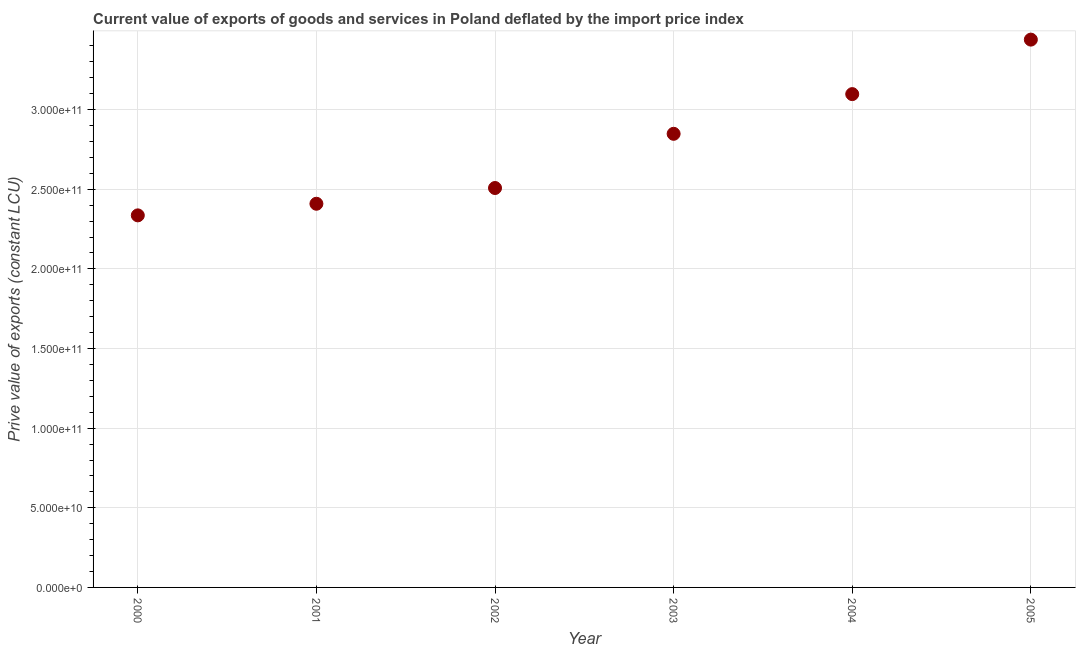What is the price value of exports in 2005?
Your answer should be very brief. 3.44e+11. Across all years, what is the maximum price value of exports?
Your answer should be compact. 3.44e+11. Across all years, what is the minimum price value of exports?
Your answer should be compact. 2.34e+11. In which year was the price value of exports maximum?
Offer a very short reply. 2005. What is the sum of the price value of exports?
Offer a terse response. 1.66e+12. What is the difference between the price value of exports in 2000 and 2003?
Your answer should be very brief. -5.12e+1. What is the average price value of exports per year?
Make the answer very short. 2.77e+11. What is the median price value of exports?
Keep it short and to the point. 2.68e+11. In how many years, is the price value of exports greater than 200000000000 LCU?
Keep it short and to the point. 6. Do a majority of the years between 2005 and 2004 (inclusive) have price value of exports greater than 160000000000 LCU?
Give a very brief answer. No. What is the ratio of the price value of exports in 2004 to that in 2005?
Provide a succinct answer. 0.9. Is the price value of exports in 2004 less than that in 2005?
Offer a very short reply. Yes. Is the difference between the price value of exports in 2001 and 2004 greater than the difference between any two years?
Provide a short and direct response. No. What is the difference between the highest and the second highest price value of exports?
Give a very brief answer. 3.42e+1. Is the sum of the price value of exports in 2002 and 2003 greater than the maximum price value of exports across all years?
Your response must be concise. Yes. What is the difference between the highest and the lowest price value of exports?
Provide a succinct answer. 1.10e+11. How many years are there in the graph?
Keep it short and to the point. 6. Does the graph contain grids?
Your response must be concise. Yes. What is the title of the graph?
Your answer should be very brief. Current value of exports of goods and services in Poland deflated by the import price index. What is the label or title of the Y-axis?
Provide a short and direct response. Prive value of exports (constant LCU). What is the Prive value of exports (constant LCU) in 2000?
Make the answer very short. 2.34e+11. What is the Prive value of exports (constant LCU) in 2001?
Make the answer very short. 2.41e+11. What is the Prive value of exports (constant LCU) in 2002?
Your answer should be very brief. 2.51e+11. What is the Prive value of exports (constant LCU) in 2003?
Offer a terse response. 2.85e+11. What is the Prive value of exports (constant LCU) in 2004?
Your response must be concise. 3.10e+11. What is the Prive value of exports (constant LCU) in 2005?
Ensure brevity in your answer.  3.44e+11. What is the difference between the Prive value of exports (constant LCU) in 2000 and 2001?
Keep it short and to the point. -7.29e+09. What is the difference between the Prive value of exports (constant LCU) in 2000 and 2002?
Your answer should be compact. -1.72e+1. What is the difference between the Prive value of exports (constant LCU) in 2000 and 2003?
Your answer should be compact. -5.12e+1. What is the difference between the Prive value of exports (constant LCU) in 2000 and 2004?
Provide a succinct answer. -7.61e+1. What is the difference between the Prive value of exports (constant LCU) in 2000 and 2005?
Keep it short and to the point. -1.10e+11. What is the difference between the Prive value of exports (constant LCU) in 2001 and 2002?
Offer a very short reply. -9.88e+09. What is the difference between the Prive value of exports (constant LCU) in 2001 and 2003?
Provide a succinct answer. -4.39e+1. What is the difference between the Prive value of exports (constant LCU) in 2001 and 2004?
Your answer should be compact. -6.88e+1. What is the difference between the Prive value of exports (constant LCU) in 2001 and 2005?
Provide a succinct answer. -1.03e+11. What is the difference between the Prive value of exports (constant LCU) in 2002 and 2003?
Give a very brief answer. -3.40e+1. What is the difference between the Prive value of exports (constant LCU) in 2002 and 2004?
Provide a succinct answer. -5.90e+1. What is the difference between the Prive value of exports (constant LCU) in 2002 and 2005?
Your answer should be compact. -9.32e+1. What is the difference between the Prive value of exports (constant LCU) in 2003 and 2004?
Offer a very short reply. -2.49e+1. What is the difference between the Prive value of exports (constant LCU) in 2003 and 2005?
Your response must be concise. -5.91e+1. What is the difference between the Prive value of exports (constant LCU) in 2004 and 2005?
Offer a very short reply. -3.42e+1. What is the ratio of the Prive value of exports (constant LCU) in 2000 to that in 2002?
Make the answer very short. 0.93. What is the ratio of the Prive value of exports (constant LCU) in 2000 to that in 2003?
Your answer should be very brief. 0.82. What is the ratio of the Prive value of exports (constant LCU) in 2000 to that in 2004?
Your answer should be compact. 0.75. What is the ratio of the Prive value of exports (constant LCU) in 2000 to that in 2005?
Your response must be concise. 0.68. What is the ratio of the Prive value of exports (constant LCU) in 2001 to that in 2003?
Make the answer very short. 0.85. What is the ratio of the Prive value of exports (constant LCU) in 2001 to that in 2004?
Your response must be concise. 0.78. What is the ratio of the Prive value of exports (constant LCU) in 2002 to that in 2003?
Your answer should be very brief. 0.88. What is the ratio of the Prive value of exports (constant LCU) in 2002 to that in 2004?
Offer a very short reply. 0.81. What is the ratio of the Prive value of exports (constant LCU) in 2002 to that in 2005?
Ensure brevity in your answer.  0.73. What is the ratio of the Prive value of exports (constant LCU) in 2003 to that in 2004?
Give a very brief answer. 0.92. What is the ratio of the Prive value of exports (constant LCU) in 2003 to that in 2005?
Your response must be concise. 0.83. What is the ratio of the Prive value of exports (constant LCU) in 2004 to that in 2005?
Your response must be concise. 0.9. 